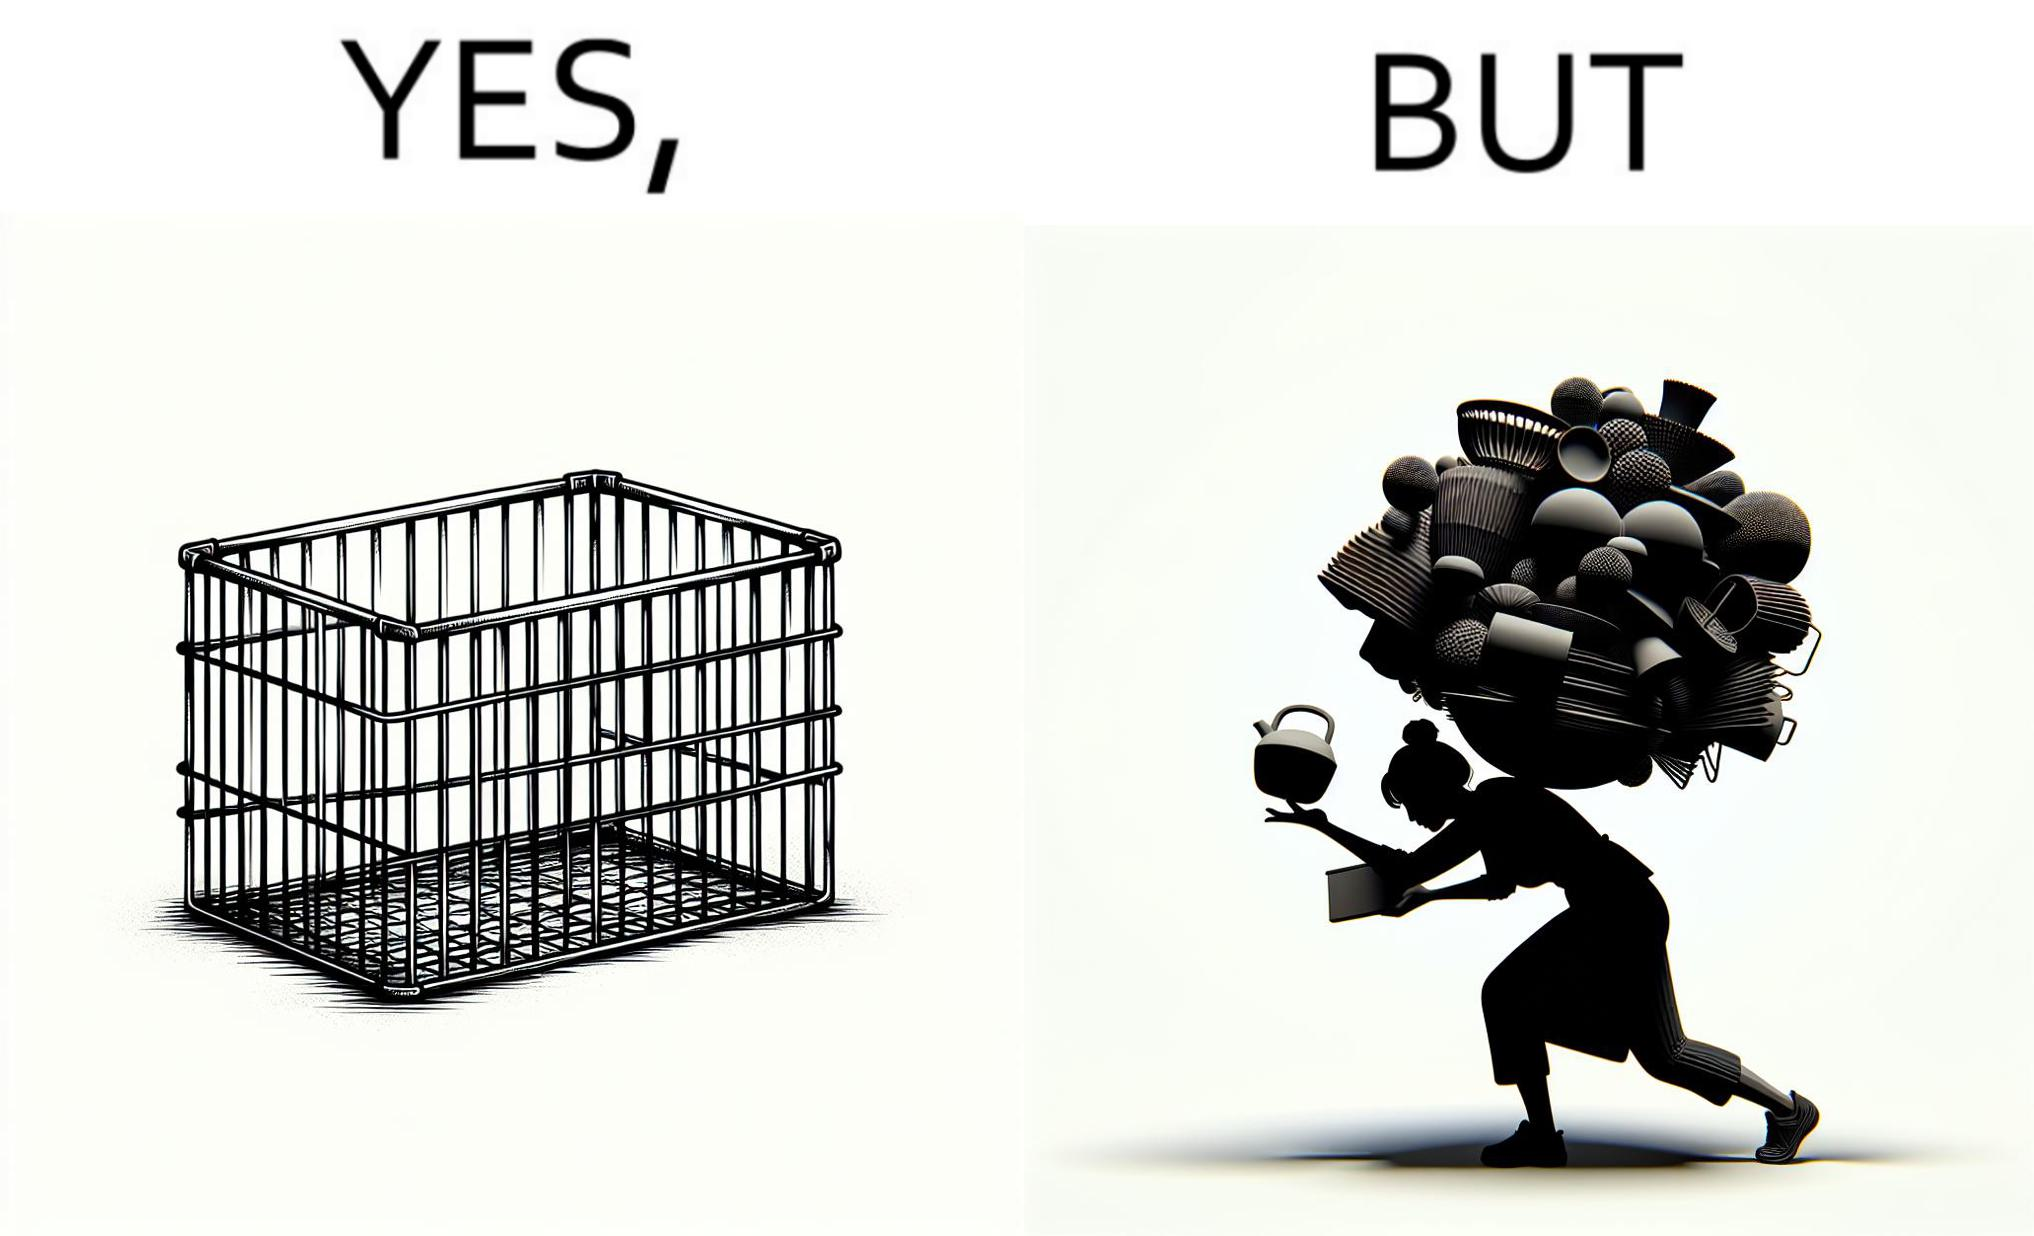Describe what you see in the left and right parts of this image. In the left part of the image: a steel frame basket In the right part of the image: a woman carrying many objects at once trying to hold them, and protecting them from falling off 